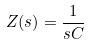<formula> <loc_0><loc_0><loc_500><loc_500>Z ( s ) = \frac { 1 } { s C }</formula> 